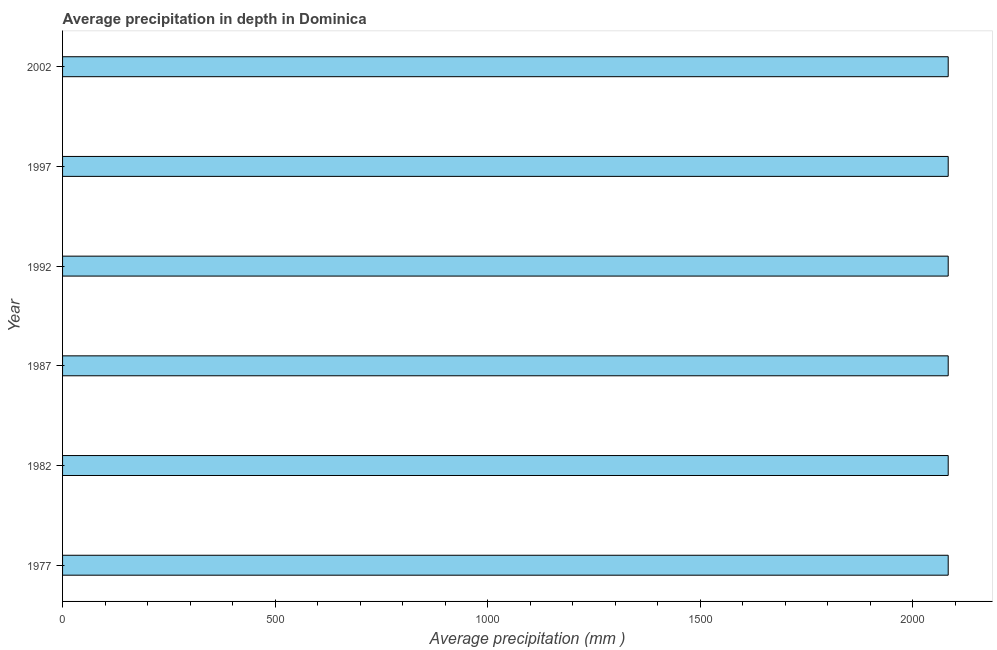Does the graph contain any zero values?
Provide a succinct answer. No. What is the title of the graph?
Your response must be concise. Average precipitation in depth in Dominica. What is the label or title of the X-axis?
Offer a very short reply. Average precipitation (mm ). What is the label or title of the Y-axis?
Your answer should be very brief. Year. What is the average precipitation in depth in 1997?
Ensure brevity in your answer.  2083. Across all years, what is the maximum average precipitation in depth?
Offer a very short reply. 2083. Across all years, what is the minimum average precipitation in depth?
Offer a very short reply. 2083. In which year was the average precipitation in depth minimum?
Provide a succinct answer. 1977. What is the sum of the average precipitation in depth?
Give a very brief answer. 1.25e+04. What is the average average precipitation in depth per year?
Give a very brief answer. 2083. What is the median average precipitation in depth?
Keep it short and to the point. 2083. In how many years, is the average precipitation in depth greater than 700 mm?
Give a very brief answer. 6. Is the average precipitation in depth in 1977 less than that in 1997?
Provide a short and direct response. No. Is the difference between the average precipitation in depth in 1992 and 2002 greater than the difference between any two years?
Provide a short and direct response. Yes. Is the sum of the average precipitation in depth in 1987 and 1997 greater than the maximum average precipitation in depth across all years?
Your answer should be very brief. Yes. What is the difference between the highest and the lowest average precipitation in depth?
Keep it short and to the point. 0. In how many years, is the average precipitation in depth greater than the average average precipitation in depth taken over all years?
Your answer should be very brief. 0. How many bars are there?
Offer a terse response. 6. How many years are there in the graph?
Offer a very short reply. 6. What is the Average precipitation (mm ) of 1977?
Make the answer very short. 2083. What is the Average precipitation (mm ) of 1982?
Provide a succinct answer. 2083. What is the Average precipitation (mm ) in 1987?
Make the answer very short. 2083. What is the Average precipitation (mm ) in 1992?
Provide a succinct answer. 2083. What is the Average precipitation (mm ) in 1997?
Your answer should be compact. 2083. What is the Average precipitation (mm ) of 2002?
Your answer should be compact. 2083. What is the difference between the Average precipitation (mm ) in 1977 and 1982?
Make the answer very short. 0. What is the difference between the Average precipitation (mm ) in 1977 and 1987?
Your answer should be compact. 0. What is the difference between the Average precipitation (mm ) in 1977 and 2002?
Offer a terse response. 0. What is the difference between the Average precipitation (mm ) in 1982 and 1987?
Give a very brief answer. 0. What is the difference between the Average precipitation (mm ) in 1982 and 1997?
Keep it short and to the point. 0. What is the difference between the Average precipitation (mm ) in 1987 and 2002?
Offer a terse response. 0. What is the difference between the Average precipitation (mm ) in 1992 and 2002?
Make the answer very short. 0. What is the ratio of the Average precipitation (mm ) in 1977 to that in 1997?
Give a very brief answer. 1. What is the ratio of the Average precipitation (mm ) in 1982 to that in 1987?
Offer a very short reply. 1. What is the ratio of the Average precipitation (mm ) in 1982 to that in 1992?
Offer a terse response. 1. What is the ratio of the Average precipitation (mm ) in 1987 to that in 1997?
Your response must be concise. 1. What is the ratio of the Average precipitation (mm ) in 1992 to that in 1997?
Give a very brief answer. 1. What is the ratio of the Average precipitation (mm ) in 1992 to that in 2002?
Your answer should be very brief. 1. What is the ratio of the Average precipitation (mm ) in 1997 to that in 2002?
Give a very brief answer. 1. 